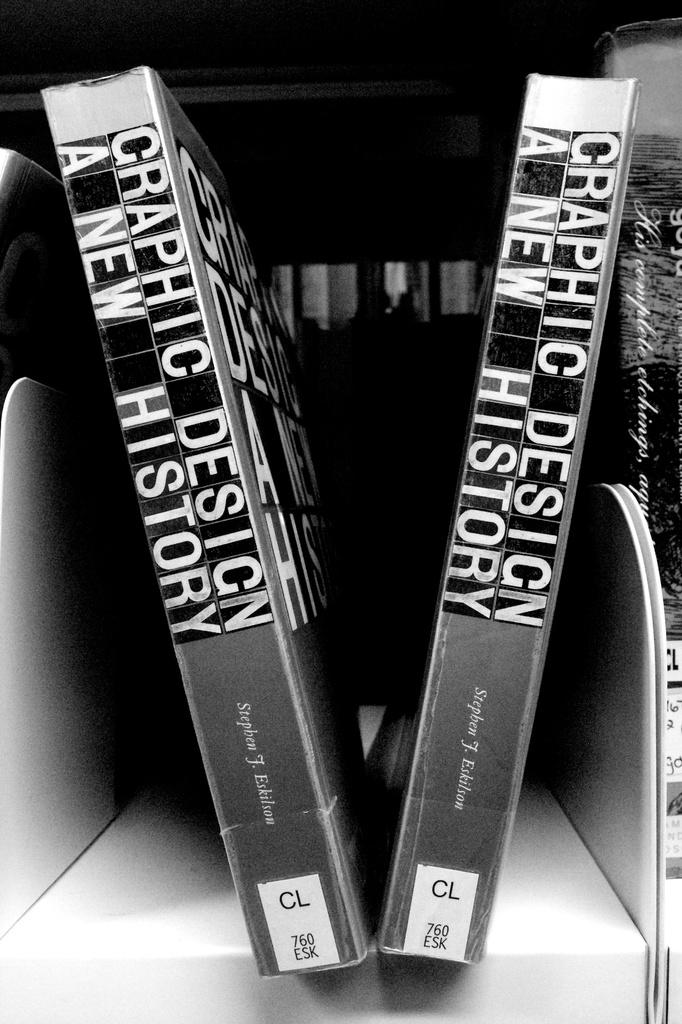<image>
Offer a succinct explanation of the picture presented. Two books sitting upright title Graphic Design a New History. 